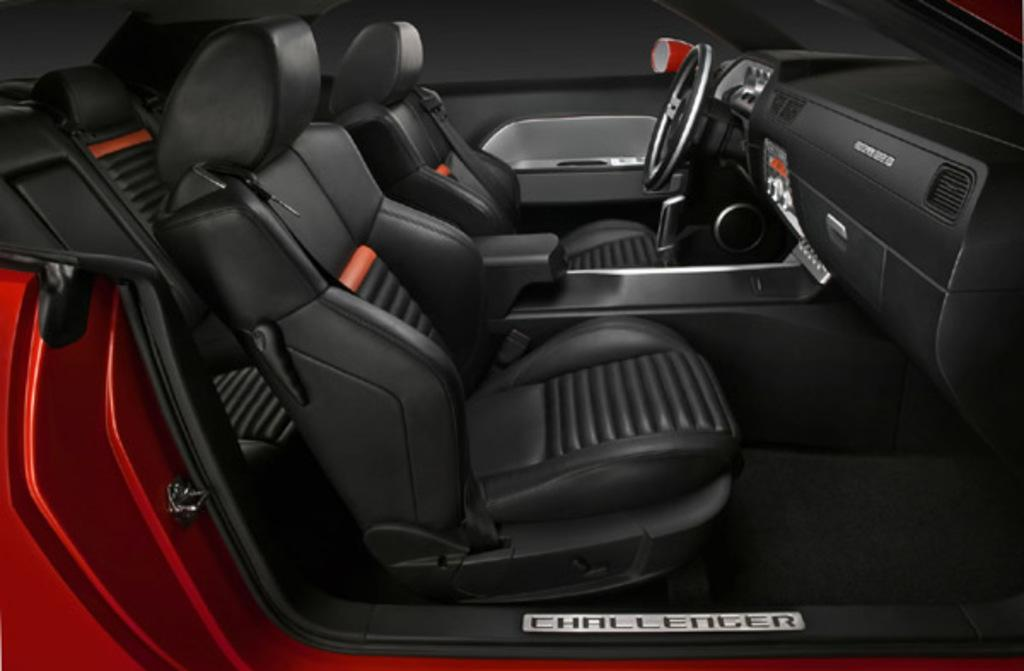What type of setting is depicted in the image? The image shows an inside view of a car. What is the color of the car in the image? The car is red in color. How many lizards can be seen inside the car's stomach in the image? There are no lizards or references to a car's stomach in the image. 